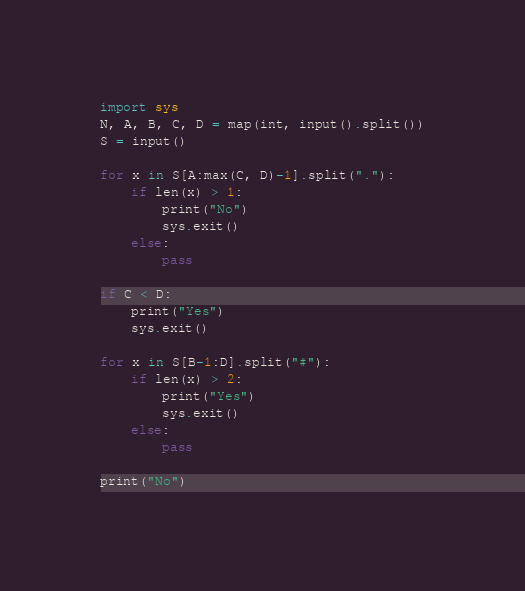<code> <loc_0><loc_0><loc_500><loc_500><_Python_>import sys
N, A, B, C, D = map(int, input().split())
S = input()

for x in S[A:max(C, D)-1].split("."):
    if len(x) > 1:
        print("No")
        sys.exit()
    else:
        pass

if C < D:
    print("Yes")
    sys.exit()

for x in S[B-1:D].split("#"):
    if len(x) > 2:
        print("Yes")
        sys.exit()
    else:
        pass

print("No")</code> 